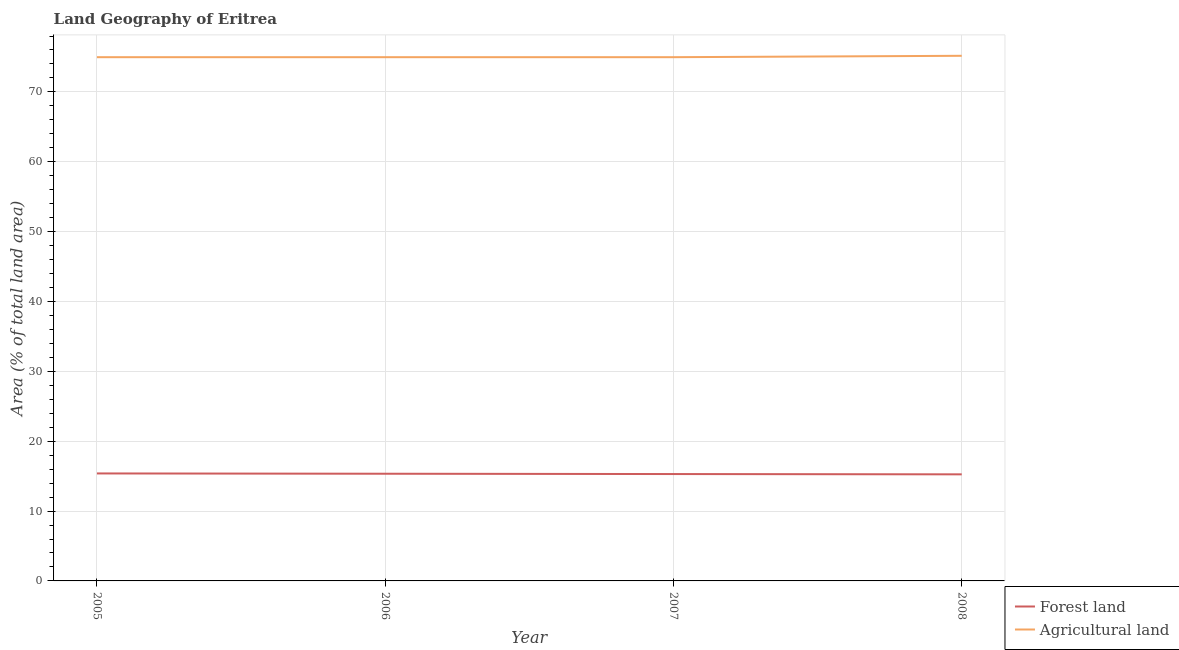How many different coloured lines are there?
Your answer should be very brief. 2. Does the line corresponding to percentage of land area under agriculture intersect with the line corresponding to percentage of land area under forests?
Ensure brevity in your answer.  No. What is the percentage of land area under agriculture in 2007?
Provide a short and direct response. 74.97. Across all years, what is the maximum percentage of land area under forests?
Ensure brevity in your answer.  15.39. Across all years, what is the minimum percentage of land area under agriculture?
Offer a very short reply. 74.97. In which year was the percentage of land area under agriculture maximum?
Offer a terse response. 2008. What is the total percentage of land area under forests in the graph?
Your answer should be compact. 61.28. What is the difference between the percentage of land area under agriculture in 2007 and that in 2008?
Keep it short and to the point. -0.2. What is the difference between the percentage of land area under agriculture in 2006 and the percentage of land area under forests in 2007?
Make the answer very short. 59.67. What is the average percentage of land area under forests per year?
Offer a terse response. 15.32. In the year 2008, what is the difference between the percentage of land area under forests and percentage of land area under agriculture?
Your response must be concise. -59.91. What is the ratio of the percentage of land area under forests in 2007 to that in 2008?
Offer a terse response. 1. Is the percentage of land area under agriculture in 2005 less than that in 2007?
Keep it short and to the point. No. What is the difference between the highest and the second highest percentage of land area under agriculture?
Offer a terse response. 0.2. What is the difference between the highest and the lowest percentage of land area under forests?
Offer a terse response. 0.13. Does the percentage of land area under agriculture monotonically increase over the years?
Your answer should be compact. No. Is the percentage of land area under agriculture strictly greater than the percentage of land area under forests over the years?
Make the answer very short. Yes. Is the percentage of land area under forests strictly less than the percentage of land area under agriculture over the years?
Make the answer very short. Yes. How many lines are there?
Keep it short and to the point. 2. Does the graph contain grids?
Offer a terse response. Yes. What is the title of the graph?
Ensure brevity in your answer.  Land Geography of Eritrea. What is the label or title of the X-axis?
Make the answer very short. Year. What is the label or title of the Y-axis?
Provide a short and direct response. Area (% of total land area). What is the Area (% of total land area) in Forest land in 2005?
Make the answer very short. 15.39. What is the Area (% of total land area) of Agricultural land in 2005?
Ensure brevity in your answer.  74.97. What is the Area (% of total land area) in Forest land in 2006?
Your response must be concise. 15.34. What is the Area (% of total land area) in Agricultural land in 2006?
Ensure brevity in your answer.  74.97. What is the Area (% of total land area) of Forest land in 2007?
Make the answer very short. 15.3. What is the Area (% of total land area) in Agricultural land in 2007?
Offer a terse response. 74.97. What is the Area (% of total land area) of Forest land in 2008?
Give a very brief answer. 15.26. What is the Area (% of total land area) in Agricultural land in 2008?
Your answer should be compact. 75.17. Across all years, what is the maximum Area (% of total land area) in Forest land?
Your response must be concise. 15.39. Across all years, what is the maximum Area (% of total land area) of Agricultural land?
Give a very brief answer. 75.17. Across all years, what is the minimum Area (% of total land area) in Forest land?
Offer a very short reply. 15.26. Across all years, what is the minimum Area (% of total land area) of Agricultural land?
Your response must be concise. 74.97. What is the total Area (% of total land area) of Forest land in the graph?
Your response must be concise. 61.28. What is the total Area (% of total land area) of Agricultural land in the graph?
Your answer should be compact. 300.08. What is the difference between the Area (% of total land area) in Forest land in 2005 and that in 2006?
Your answer should be compact. 0.04. What is the difference between the Area (% of total land area) in Forest land in 2005 and that in 2007?
Give a very brief answer. 0.09. What is the difference between the Area (% of total land area) of Forest land in 2005 and that in 2008?
Make the answer very short. 0.13. What is the difference between the Area (% of total land area) in Agricultural land in 2005 and that in 2008?
Your answer should be very brief. -0.2. What is the difference between the Area (% of total land area) in Forest land in 2006 and that in 2007?
Keep it short and to the point. 0.04. What is the difference between the Area (% of total land area) of Agricultural land in 2006 and that in 2007?
Your response must be concise. 0. What is the difference between the Area (% of total land area) of Forest land in 2006 and that in 2008?
Give a very brief answer. 0.09. What is the difference between the Area (% of total land area) of Agricultural land in 2006 and that in 2008?
Provide a short and direct response. -0.2. What is the difference between the Area (% of total land area) in Forest land in 2007 and that in 2008?
Offer a very short reply. 0.04. What is the difference between the Area (% of total land area) in Agricultural land in 2007 and that in 2008?
Keep it short and to the point. -0.2. What is the difference between the Area (% of total land area) of Forest land in 2005 and the Area (% of total land area) of Agricultural land in 2006?
Make the answer very short. -59.58. What is the difference between the Area (% of total land area) of Forest land in 2005 and the Area (% of total land area) of Agricultural land in 2007?
Make the answer very short. -59.58. What is the difference between the Area (% of total land area) in Forest land in 2005 and the Area (% of total land area) in Agricultural land in 2008?
Make the answer very short. -59.78. What is the difference between the Area (% of total land area) of Forest land in 2006 and the Area (% of total land area) of Agricultural land in 2007?
Ensure brevity in your answer.  -59.63. What is the difference between the Area (% of total land area) in Forest land in 2006 and the Area (% of total land area) in Agricultural land in 2008?
Ensure brevity in your answer.  -59.83. What is the difference between the Area (% of total land area) of Forest land in 2007 and the Area (% of total land area) of Agricultural land in 2008?
Give a very brief answer. -59.87. What is the average Area (% of total land area) of Forest land per year?
Provide a short and direct response. 15.32. What is the average Area (% of total land area) of Agricultural land per year?
Your response must be concise. 75.02. In the year 2005, what is the difference between the Area (% of total land area) in Forest land and Area (% of total land area) in Agricultural land?
Provide a short and direct response. -59.58. In the year 2006, what is the difference between the Area (% of total land area) of Forest land and Area (% of total land area) of Agricultural land?
Give a very brief answer. -59.63. In the year 2007, what is the difference between the Area (% of total land area) in Forest land and Area (% of total land area) in Agricultural land?
Provide a short and direct response. -59.67. In the year 2008, what is the difference between the Area (% of total land area) of Forest land and Area (% of total land area) of Agricultural land?
Your answer should be very brief. -59.91. What is the ratio of the Area (% of total land area) of Agricultural land in 2005 to that in 2006?
Ensure brevity in your answer.  1. What is the ratio of the Area (% of total land area) in Forest land in 2005 to that in 2007?
Give a very brief answer. 1.01. What is the ratio of the Area (% of total land area) in Forest land in 2005 to that in 2008?
Provide a succinct answer. 1.01. What is the ratio of the Area (% of total land area) in Forest land in 2006 to that in 2007?
Ensure brevity in your answer.  1. What is the ratio of the Area (% of total land area) in Forest land in 2006 to that in 2008?
Provide a succinct answer. 1.01. What is the ratio of the Area (% of total land area) in Agricultural land in 2006 to that in 2008?
Your answer should be compact. 1. What is the difference between the highest and the second highest Area (% of total land area) in Forest land?
Offer a terse response. 0.04. What is the difference between the highest and the second highest Area (% of total land area) in Agricultural land?
Make the answer very short. 0.2. What is the difference between the highest and the lowest Area (% of total land area) of Forest land?
Give a very brief answer. 0.13. What is the difference between the highest and the lowest Area (% of total land area) of Agricultural land?
Your response must be concise. 0.2. 